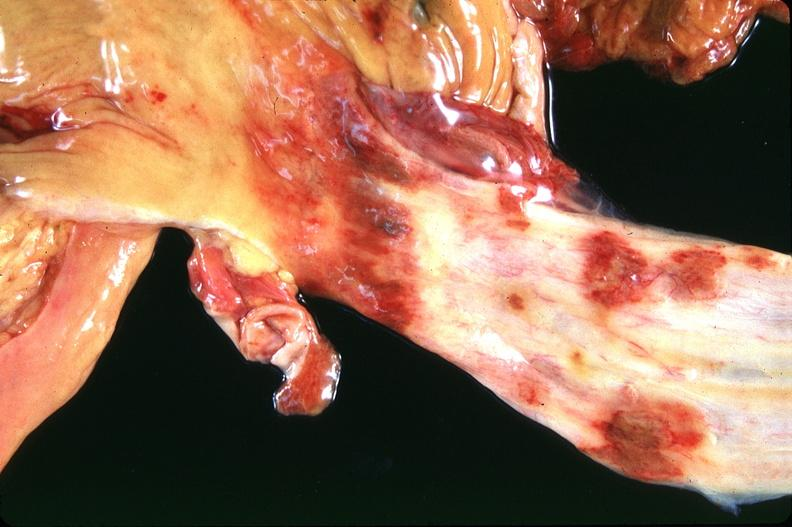where does this belong to?
Answer the question using a single word or phrase. Gastrointestinal system 